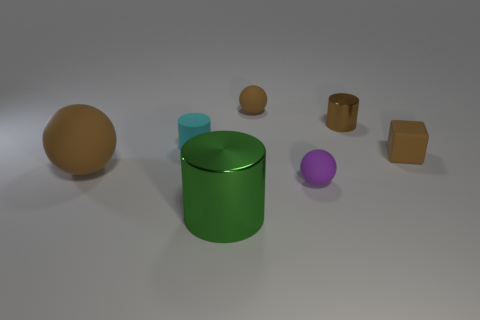Is there anything else that has the same shape as the big brown matte thing?
Ensure brevity in your answer.  Yes. There is a tiny sphere that is in front of the matte cube; does it have the same color as the thing to the right of the brown metal cylinder?
Your answer should be very brief. No. Are there any small yellow rubber balls?
Provide a succinct answer. No. There is a big thing that is the same color as the block; what is its material?
Give a very brief answer. Rubber. There is a brown matte sphere in front of the tiny brown rubber thing that is behind the small brown matte object on the right side of the small purple object; what size is it?
Keep it short and to the point. Large. There is a cyan rubber thing; does it have the same shape as the brown matte thing that is behind the cyan rubber thing?
Offer a very short reply. No. Is there another ball of the same color as the large ball?
Your response must be concise. Yes. How many spheres are either tiny purple rubber things or large brown rubber things?
Offer a terse response. 2. Are there any large brown matte things that have the same shape as the tiny purple object?
Offer a terse response. Yes. What number of other things are there of the same color as the large metallic object?
Provide a succinct answer. 0. 